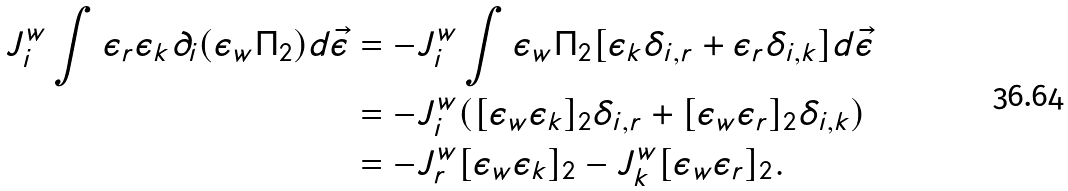<formula> <loc_0><loc_0><loc_500><loc_500>J _ { i } ^ { w } \int \epsilon _ { r } \epsilon _ { k } \partial _ { i } ( \epsilon _ { w } \Pi _ { 2 } ) d { \vec { \epsilon } } & = - J _ { i } ^ { w } \int \epsilon _ { w } \Pi _ { 2 } [ \epsilon _ { k } \delta _ { i , r } + \epsilon _ { r } \delta _ { i , k } ] d { \vec { \epsilon } } \\ & = - J _ { i } ^ { w } ( [ \epsilon _ { w } \epsilon _ { k } ] _ { 2 } \delta _ { i , r } + [ \epsilon _ { w } \epsilon _ { r } ] _ { 2 } \delta _ { i , k } ) \\ & = - J _ { r } ^ { w } [ \epsilon _ { w } \epsilon _ { k } ] _ { 2 } - J _ { k } ^ { w } [ \epsilon _ { w } \epsilon _ { r } ] _ { 2 } .</formula> 